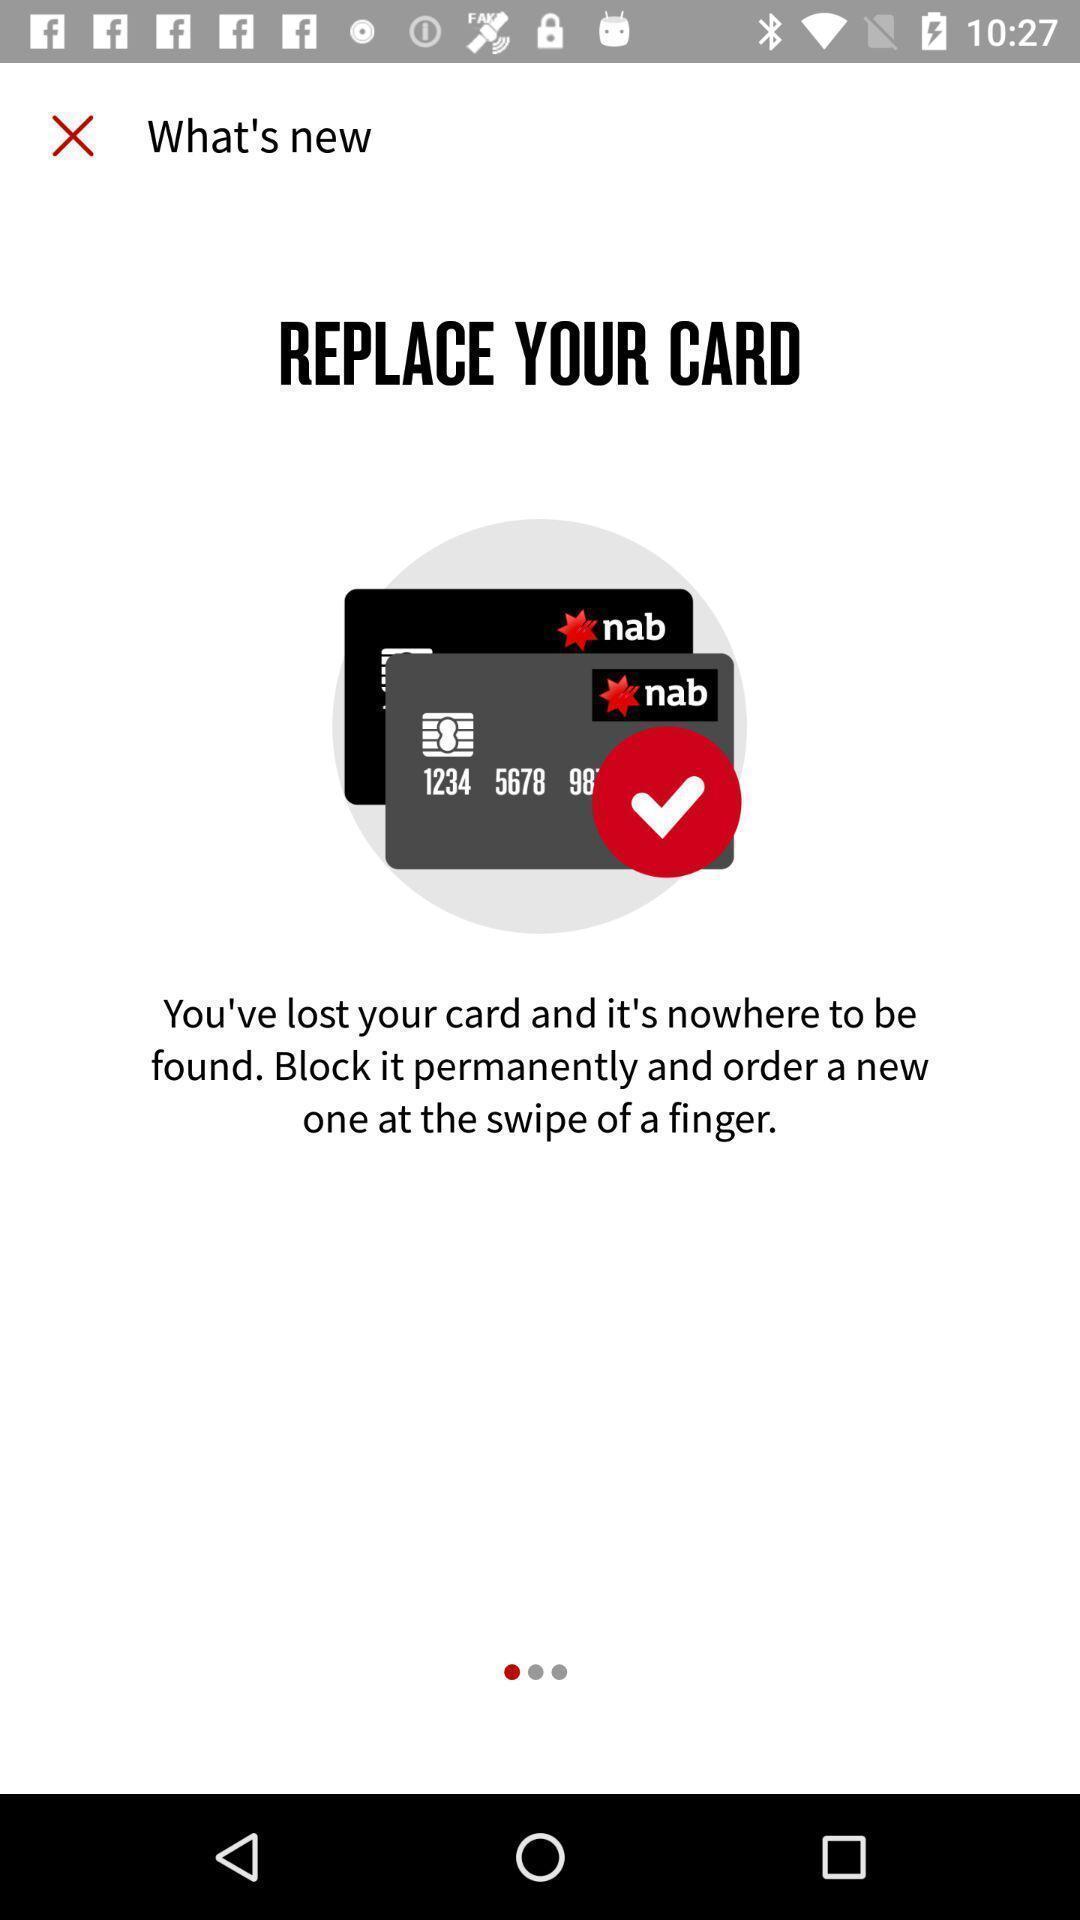Please provide a description for this image. Screen displaying the new update. 